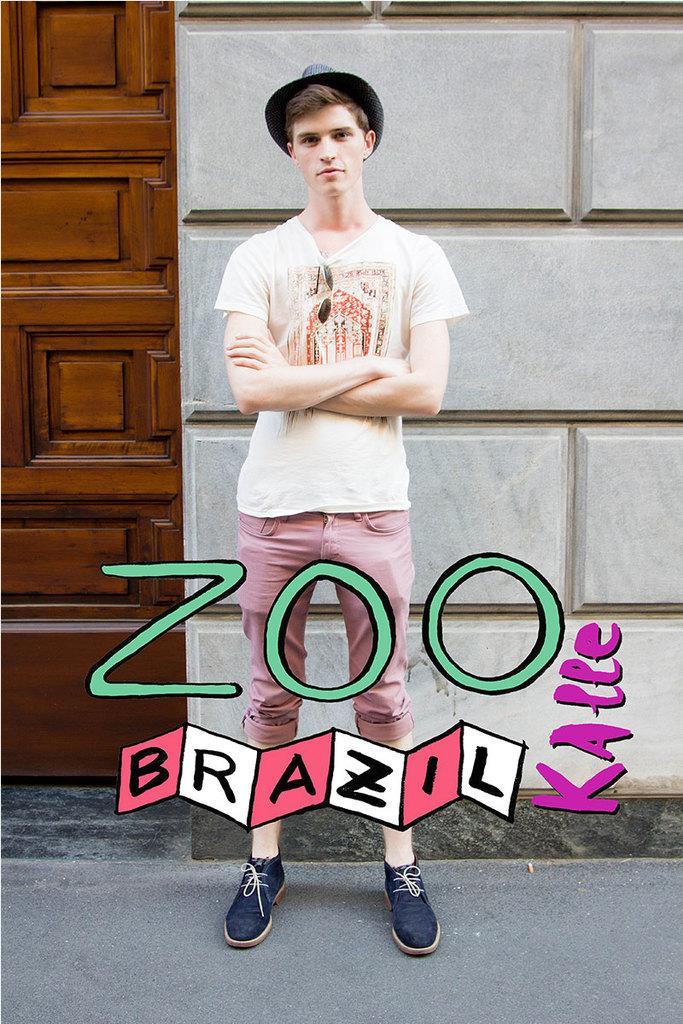Can you describe this image briefly? In this image there is a boy standing in front of the building, beside that there is a door. 